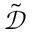Convert formula to latex. <formula><loc_0><loc_0><loc_500><loc_500>\tilde { \mathcal { D } }</formula> 